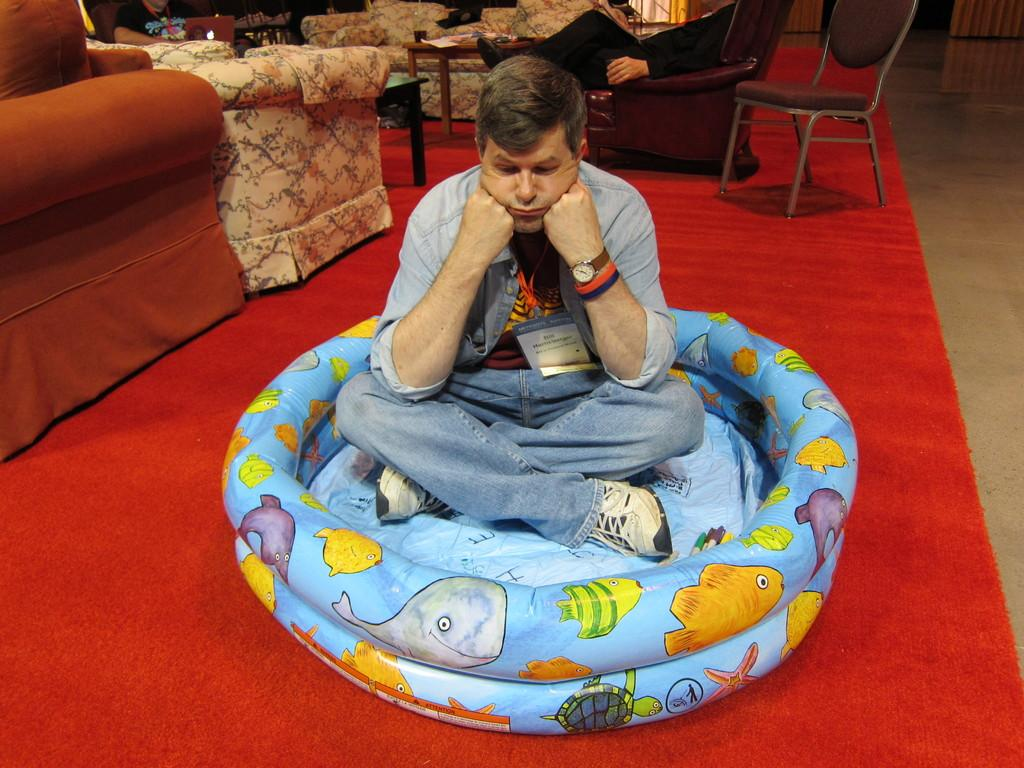What is the man doing in the image? The man is sitting on a balloon-type tub in the image. What is the man doing with his hands? The man has his hands on his cheeks. What can be seen in the background of the image? In the background, there is a person sitting on a chair, a person sitting on a sofa, a table, and a mattress. What type of ornament is hanging from the man's arm in the image? There is no ornament hanging from the man's arm in the image. How does the man start the balloon-type tub in the image? The image does not show the man starting the balloon-type tub, as it is a still image. 